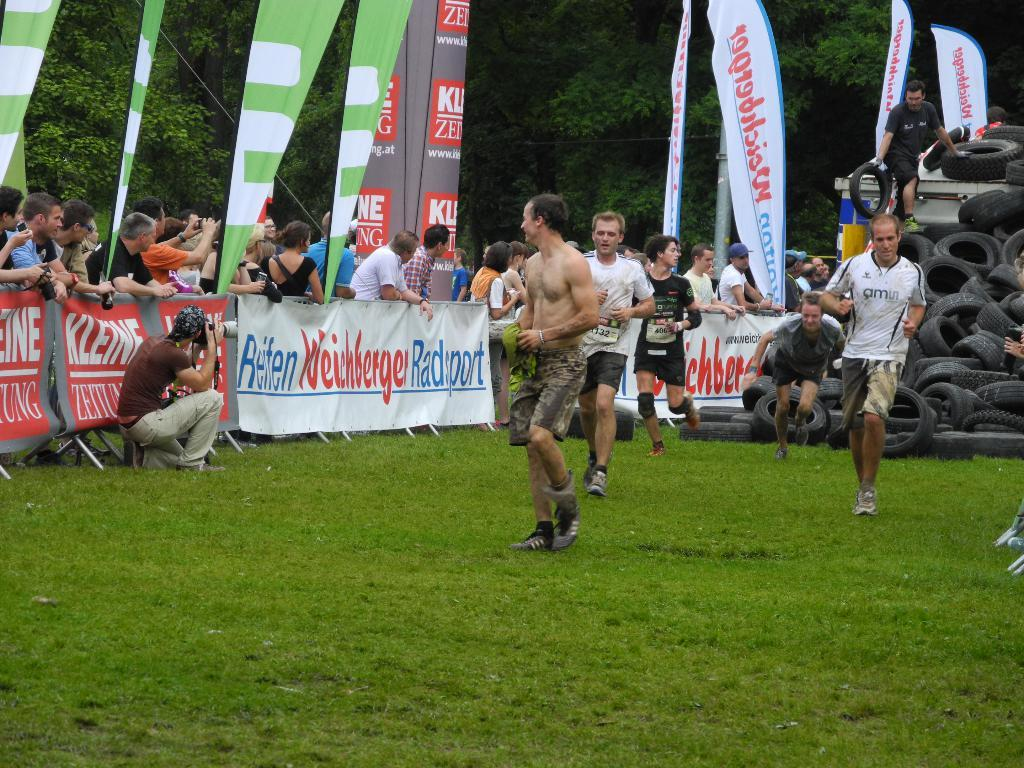<image>
Give a short and clear explanation of the subsequent image. guys running on field with a pile of tires in the back and a sponsor sign for reifen weichbergen radsport 